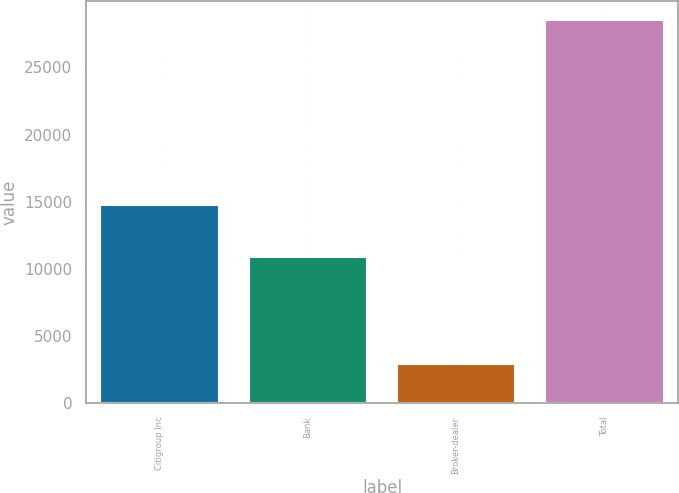Convert chart. <chart><loc_0><loc_0><loc_500><loc_500><bar_chart><fcel>Citigroup Inc<fcel>Bank<fcel>Broker-dealer<fcel>Total<nl><fcel>14758<fcel>10877<fcel>2907<fcel>28542<nl></chart> 